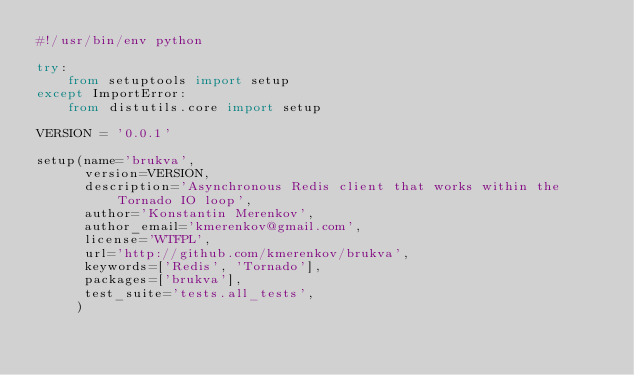<code> <loc_0><loc_0><loc_500><loc_500><_Python_>#!/usr/bin/env python

try:
    from setuptools import setup
except ImportError:
    from distutils.core import setup

VERSION = '0.0.1'

setup(name='brukva',
      version=VERSION,
      description='Asynchronous Redis client that works within the Tornado IO loop',
      author='Konstantin Merenkov',
      author_email='kmerenkov@gmail.com',
      license='WTFPL',
      url='http://github.com/kmerenkov/brukva',
      keywords=['Redis', 'Tornado'],
      packages=['brukva'],
      test_suite='tests.all_tests',
     )
</code> 